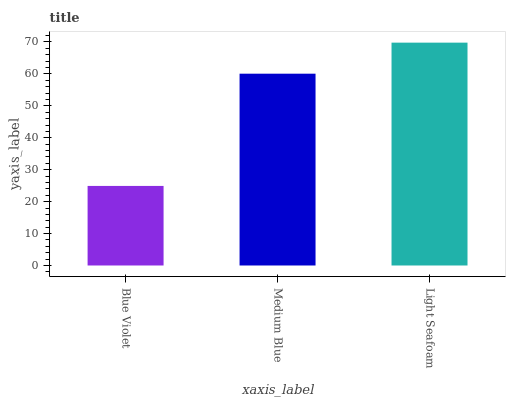Is Blue Violet the minimum?
Answer yes or no. Yes. Is Light Seafoam the maximum?
Answer yes or no. Yes. Is Medium Blue the minimum?
Answer yes or no. No. Is Medium Blue the maximum?
Answer yes or no. No. Is Medium Blue greater than Blue Violet?
Answer yes or no. Yes. Is Blue Violet less than Medium Blue?
Answer yes or no. Yes. Is Blue Violet greater than Medium Blue?
Answer yes or no. No. Is Medium Blue less than Blue Violet?
Answer yes or no. No. Is Medium Blue the high median?
Answer yes or no. Yes. Is Medium Blue the low median?
Answer yes or no. Yes. Is Blue Violet the high median?
Answer yes or no. No. Is Light Seafoam the low median?
Answer yes or no. No. 